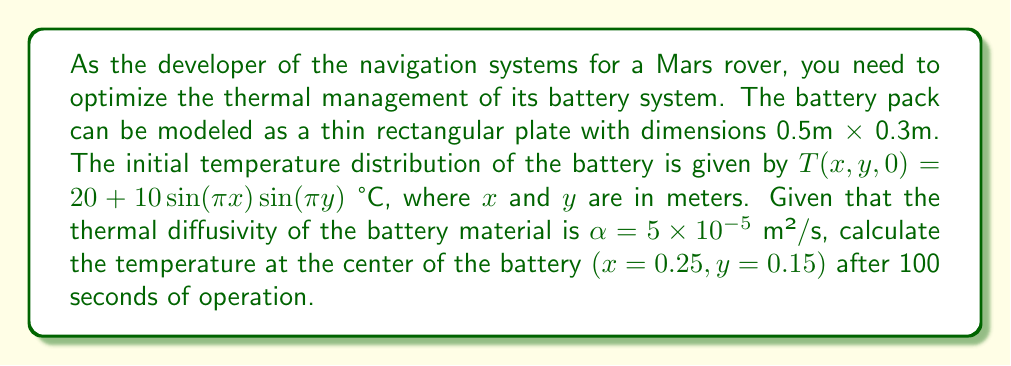Show me your answer to this math problem. To solve this problem, we need to use the 2D heat equation and apply separation of variables. Let's break it down step-by-step:

1) The 2D heat equation is given by:
   $$\frac{\partial T}{\partial t} = \alpha\left(\frac{\partial^2 T}{\partial x^2} + \frac{\partial^2 T}{\partial y^2}\right)$$

2) The initial condition is:
   $$T(x,y,0) = 20 + 10\sin(\pi x)\sin(\pi y)$$

3) We can separate the solution into steady-state and transient parts:
   $$T(x,y,t) = 20 + 10\sin(\pi x)\sin(\pi y)e^{-\alpha(\pi^2+\pi^2)t}$$

4) The exponential term represents the decay of the initial temperature distribution over time.

5) Now, let's substitute the given values:
   $x = 0.25$ m
   $y = 0.15$ m
   $t = 100$ s
   $\alpha = 5 \times 10^{-5}$ m²/s

6) Calculating the temperature:
   $$T(0.25,0.15,100) = 20 + 10\sin(\pi \cdot 0.25)\sin(\pi \cdot 0.15)e^{-5 \times 10^{-5}(2\pi^2)100}$$

7) Simplify:
   $$T(0.25,0.15,100) = 20 + 10 \cdot 0.7071 \cdot 0.4539 \cdot e^{-0.0987}$$
   $$T(0.25,0.15,100) = 20 + 3.2092 \cdot 0.9060$$
   $$T(0.25,0.15,100) = 20 + 2.9075$$
   $$T(0.25,0.15,100) = 22.9075 \text{ °C}$$
Answer: 22.91 °C 